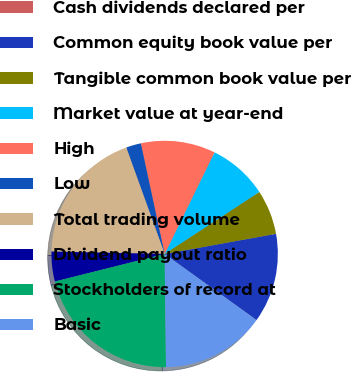<chart> <loc_0><loc_0><loc_500><loc_500><pie_chart><fcel>Cash dividends declared per<fcel>Common equity book value per<fcel>Tangible common book value per<fcel>Market value at year-end<fcel>High<fcel>Low<fcel>Total trading volume<fcel>Dividend payout ratio<fcel>Stockholders of record at<fcel>Basic<nl><fcel>0.0%<fcel>12.77%<fcel>6.38%<fcel>8.51%<fcel>10.64%<fcel>2.13%<fcel>19.15%<fcel>4.26%<fcel>21.28%<fcel>14.89%<nl></chart> 